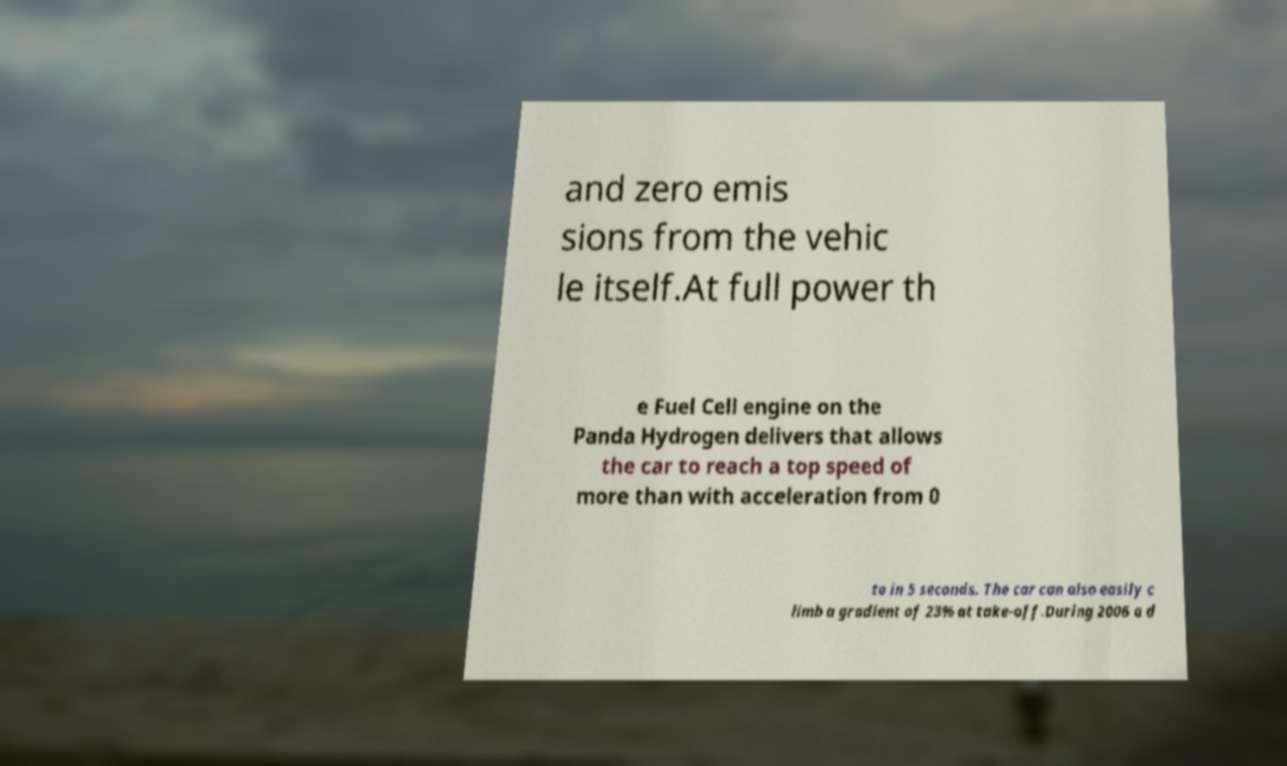Can you read and provide the text displayed in the image?This photo seems to have some interesting text. Can you extract and type it out for me? and zero emis sions from the vehic le itself.At full power th e Fuel Cell engine on the Panda Hydrogen delivers that allows the car to reach a top speed of more than with acceleration from 0 to in 5 seconds. The car can also easily c limb a gradient of 23% at take-off.During 2006 a d 